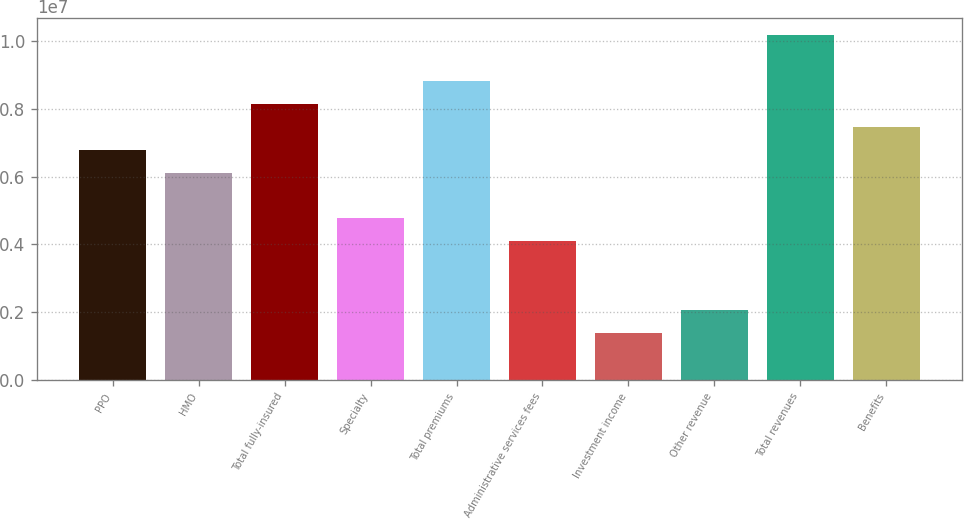<chart> <loc_0><loc_0><loc_500><loc_500><bar_chart><fcel>PPO<fcel>HMO<fcel>Total fully-insured<fcel>Specialty<fcel>Total premiums<fcel>Administrative services fees<fcel>Investment income<fcel>Other revenue<fcel>Total revenues<fcel>Benefits<nl><fcel>6.79478e+06<fcel>6.11844e+06<fcel>8.14747e+06<fcel>4.76575e+06<fcel>8.82381e+06<fcel>4.08941e+06<fcel>1.38404e+06<fcel>2.06038e+06<fcel>1.01765e+07<fcel>7.47113e+06<nl></chart> 